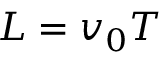Convert formula to latex. <formula><loc_0><loc_0><loc_500><loc_500>L = v _ { 0 } T</formula> 